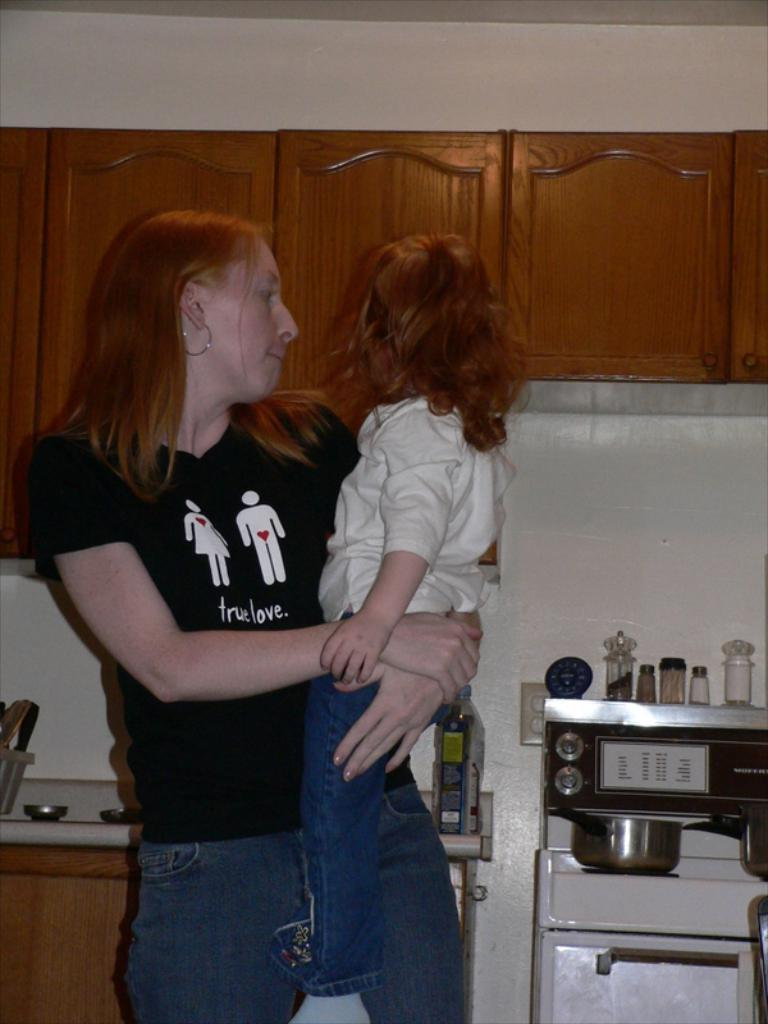Provide a one-sentence caption for the provided image. a lady with a shirt on that says true love. 